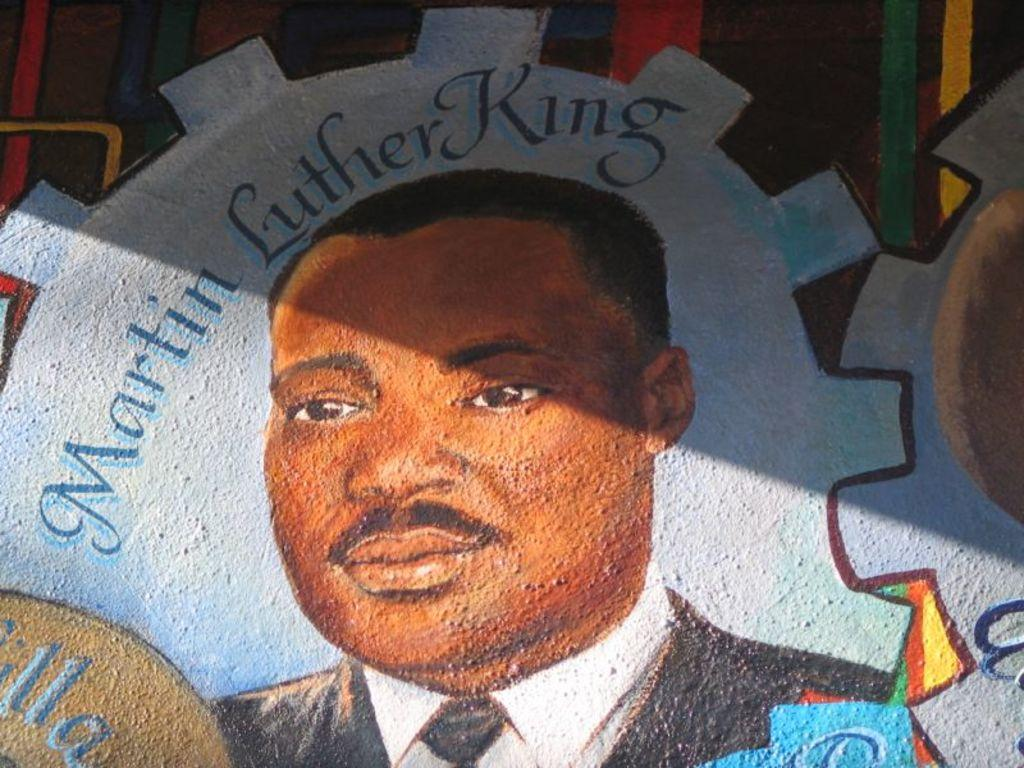What is the main subject in the center of the image? There is a wall in the center of the image. What is depicted on the wall? There is a painting of Martin Luther King on the wall. What type of plastic ring can be seen on Martin Luther King's finger in the painting? There is no plastic ring visible on Martin Luther King's finger in the painting. 